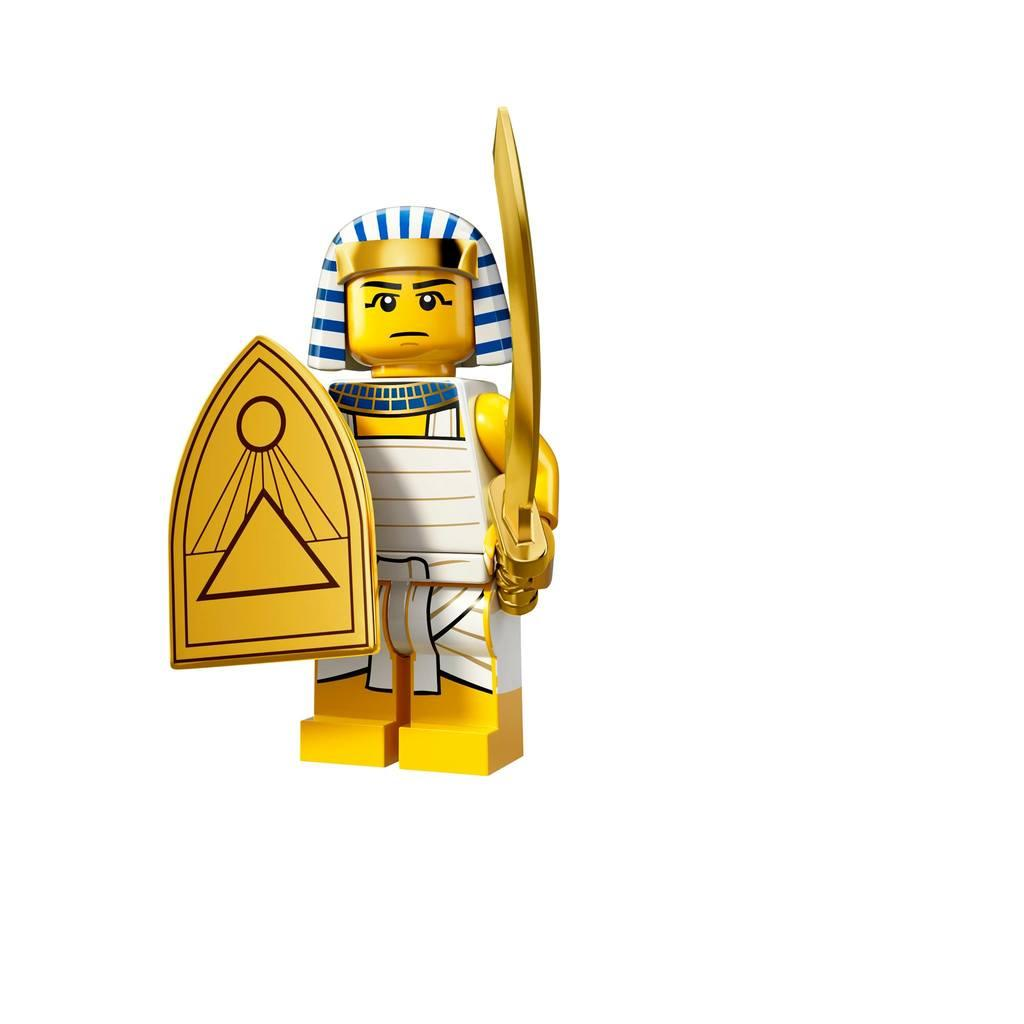What type of content is depicted in the image? There is a cartoon in the image. How many scenes can be seen in the cartoon's stomach in the image? There is no stomach or scenes present in the cartoon, as it is a two-dimensional image. 